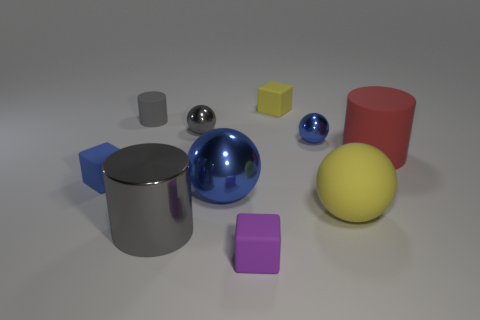How many big blue spheres are behind the tiny matte cube behind the tiny blue block? 0 